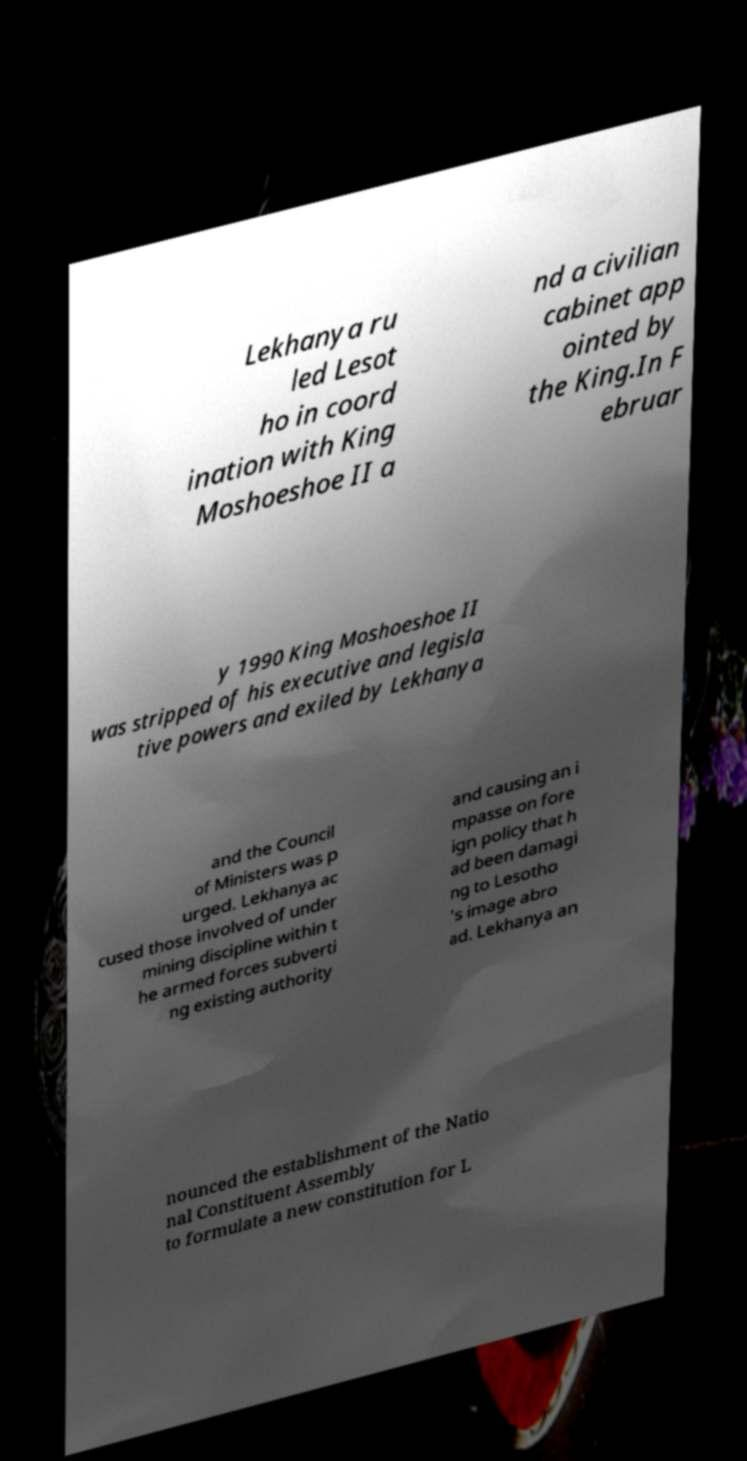I need the written content from this picture converted into text. Can you do that? Lekhanya ru led Lesot ho in coord ination with King Moshoeshoe II a nd a civilian cabinet app ointed by the King.In F ebruar y 1990 King Moshoeshoe II was stripped of his executive and legisla tive powers and exiled by Lekhanya and the Council of Ministers was p urged. Lekhanya ac cused those involved of under mining discipline within t he armed forces subverti ng existing authority and causing an i mpasse on fore ign policy that h ad been damagi ng to Lesotho 's image abro ad. Lekhanya an nounced the establishment of the Natio nal Constituent Assembly to formulate a new constitution for L 